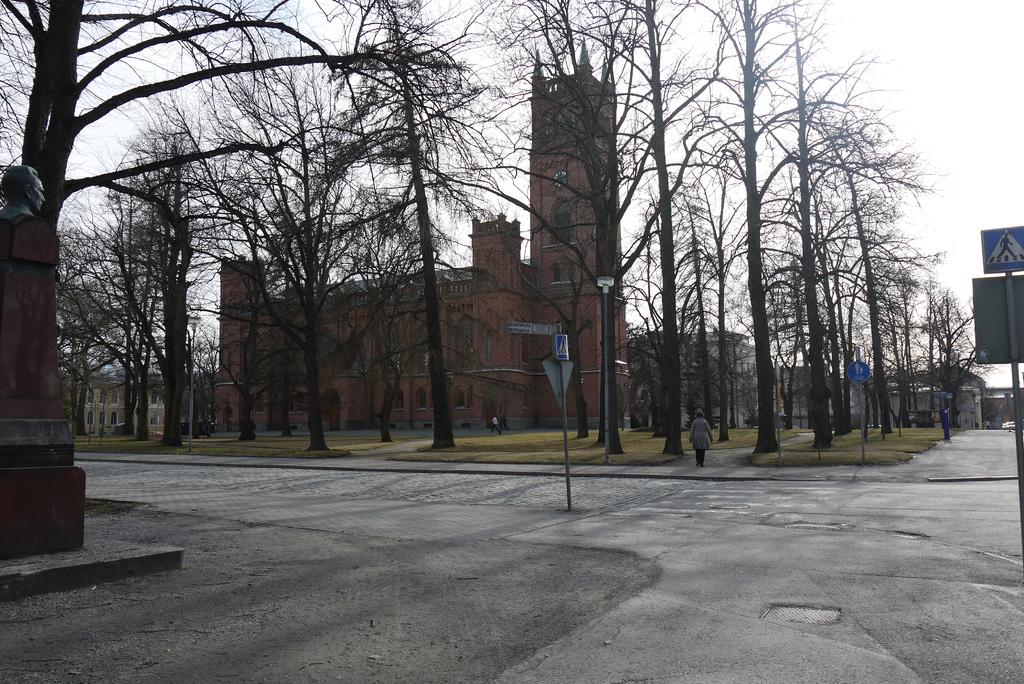What is the main subject of the image? There is a person standing on the ground in the image. What structures can be seen in the image? Street poles, street lights, sign boards, a statue, a pedestal, and buildings are visible in the image. What type of vegetation is present in the image? Trees are present in the image. What is visible in the background of the image? The sky is visible in the background of the image. What type of grip does the celery have on the statue in the image? There is no celery present in the image, and therefore no grip can be observed. 